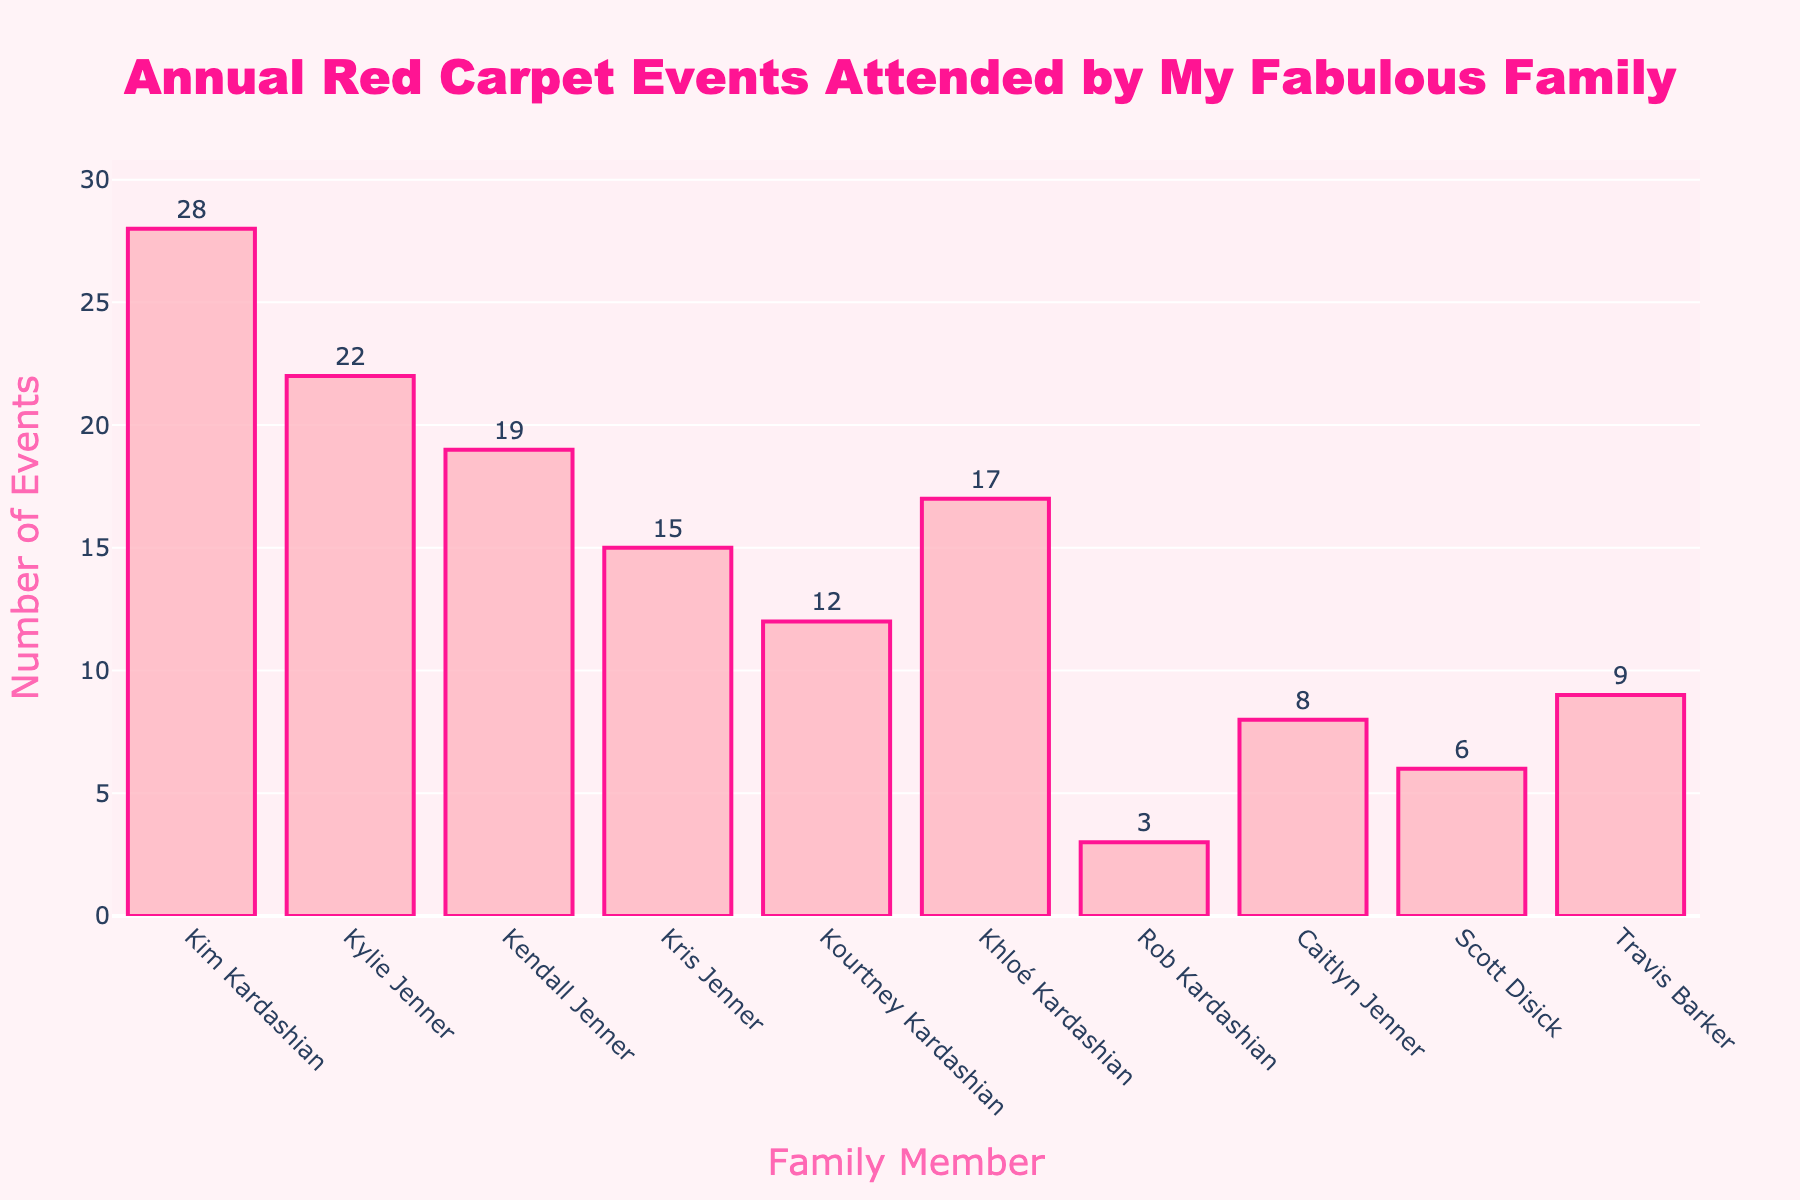how many red carpet events did Kim Kardashian attend? To find this, simply look for Kim Kardashian's bar in the histogram and check the value at the top of the bar.
Answer: 28 Which family member attended the fewest red carpet events? Identify the shortest bar in the histogram and read the associated family member's name.
Answer: Rob Kardashian Who attended more red carpet events: Kendall Jenner or Khloé Kardashian? Compare the bars for Kendall Jenner and Khloé Kardashian by looking at their heights.
Answer: Kendall Jenner What's the total number of red carpet events attended by the Kardashian family members? Sum the values at the top of each bar labeled with a Kardashian: Kim (28), Kylie (22), Kendall (19), Kris (15), Kourtney (12), Khloé (17), Rob (3). So, 28 + 22 + 19 + 15 + 12 + 17 + 3 = 116
Answer: 116 Which family members attended more than 20 red carpet events? Find the bars with values greater than 20 and note their corresponding family members: Kim Kardashian (28) and Kylie Jenner (22).
Answer: Kim Kardashian, Kylie Jenner Who had the middle (median) number of red carpet events attended if we list all events in order? Order the values: 3, 6, 8, 9, 12, 15, 17, 19, 22, 28. The middle value (5th and 6th positions in an even list) are 12 and 15. Thus, the median is (12+15)/2 = 13.5
Answer: 13.5 How many more events did Kim Kardashian attend compared to Scott Disick? Subtract the number of events attended by Scott Disick from those attended by Kim Kardashian: 28 - 6 = 22
Answer: 22 Which Jenner family member attended the fewest red carpet events? Identify the shortest bar among the Jenner family members (Kylie, Kendall, Kris, Caitlyn). Caitlyn Jenner attended 8 events.
Answer: Caitlyn Jenner What's the average number of red carpet events for just the Jenner family members? Sum the values for Jenner members (Kylie 22, Kendall 19, Kris 15, Caitlyn 8) and divide by the number of these members: (22 + 19 + 15 + 8) / 4 = 64 / 4 = 16
Answer: 16 How many family members attended fewer than 10 red carpet events? Identify the bars with values less than 10: Rob Kardashian (3), Caitlyn Jenner (8), Scott Disick (6). Count these members, which is 3.
Answer: 3 